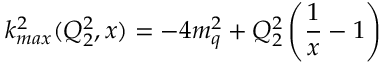<formula> <loc_0><loc_0><loc_500><loc_500>k _ { \max } ^ { 2 } ( Q _ { 2 } ^ { 2 } , x ) = - 4 m _ { q } ^ { 2 } + Q _ { 2 } ^ { 2 } \left ( { \frac { 1 } { x } } - 1 \right )</formula> 